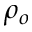<formula> <loc_0><loc_0><loc_500><loc_500>\rho _ { o }</formula> 